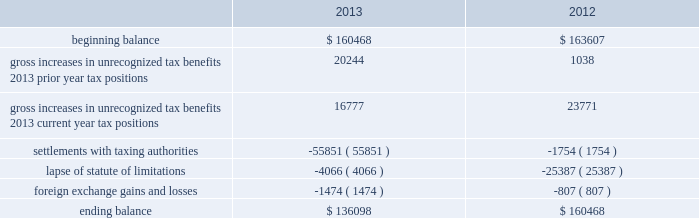Adobe systems incorporated notes to consolidated financial statements ( continued ) accounting for uncertainty in income taxes during fiscal 2013 and 2012 , our aggregate changes in our total gross amount of unrecognized tax benefits are summarized as follows ( in thousands ) : .
As of november 29 , 2013 , the combined amount of accrued interest and penalties related to tax positions taken on our tax returns and included in non-current income taxes payable was approximately $ 11.4 million .
We file income tax returns in the u.s .
On a federal basis and in many u.s .
State and foreign jurisdictions .
We are subject to the continual examination of our income tax returns by the irs and other domestic and foreign tax authorities .
Our major tax jurisdictions are the u.s. , ireland and california .
For california , ireland and the u.s. , the earliest fiscal years open for examination are 2005 , 2006 and 2010 , respectively .
We regularly assess the likelihood of outcomes resulting from these examinations to determine the adequacy of our provision for income taxes and have reserved for potential adjustments that may result from the current examinations .
We believe such estimates to be reasonable ; however , there can be no assurance that the final determination of any of these examinations will not have an adverse effect on our operating results and financial position .
In july 2013 , a u.s .
Income tax examination covering our fiscal years 2008 and 2009 was completed .
Our accrued tax and interest related to these years was $ 48.4 million and was previously reported in long-term income taxes payable .
We settled the tax obligation resulting from this examination with cash and income tax assets totaling $ 41.2 million , and the resulting $ 7.2 million income tax benefit was recorded in the third quarter of fiscal 2013 .
The timing of the resolution of income tax examinations is highly uncertain as are the amounts and timing of tax payments that are part of any audit settlement process .
These events could cause large fluctuations in the balance sheet classification of current and non-current assets and liabilities .
We believe that within the next 12 months , it is reasonably possible that either certain audits will conclude or statutes of limitations on certain income tax examination periods will expire , or both .
Given the uncertainties described above , we can only determine a range of estimated potential decreases in underlying unrecognized tax benefits ranging from $ 0 to approximately $ 5 million .
Note 10 .
Restructuring fiscal 2011 restructuring plan in the fourth quarter of fiscal 2011 , we initiated a restructuring plan consisting of reductions in workforce and the consolidation of facilities in order to better align our resources around our digital media and digital marketing strategies .
During fiscal 2013 , we continued to implement restructuring activities under this plan .
Total costs incurred to date and expected to be incurred for closing redundant facilities are $ 12.2 million as all facilities under this plan have been exited as of november 29 , 2013 .
Other restructuring plans other restructuring plans include other adobe plans and other plans associated with certain of our acquisitions that are substantially complete .
We continue to make cash outlays to settle obligations under these plans , however the current impact to our consolidated financial statements is not significant .
Our other restructuring plans primarily consist of the 2009 restructuring plan , which was implemented in the fourth quarter of fiscal 2009 , in order to appropriately align our costs in connection with our fiscal 2010 operating plan. .
For the july 2013 settled examination , what percentage of the cash and income tax assets in the settlement was represented by income tax benefit recorded in the third quarter of fiscal 2013? 
Computations: (7.2 / 41.2)
Answer: 0.17476. 